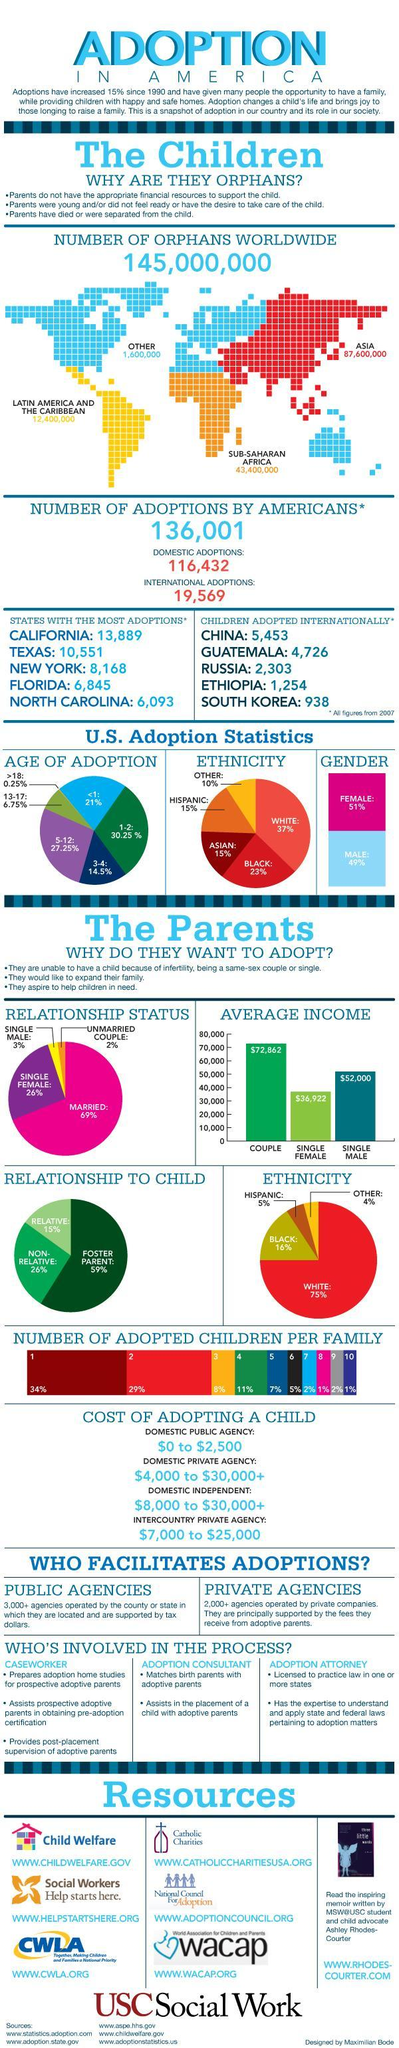What percentage of Asians go for adoption?
Answer the question with a short phrase. 15% What is the average income of single female parent? $36,922 Couples or people in what relationship adopt maximum? MARRIED How many children from China were adopted in 2007? 5,453 In what percentage of cases are the children non-related? 26% Who is responsible for legal adoption matters? ADOPTION ATTORNEY Which gender is higher in adoption statistics? FEMALE What is the age of adoption of 27.25% of children? 5-12 Which ethnicity tops the pie chart in terms of ethnicity? WHITE Who charges the least while adopting? DOMESTIC PUBLIC AGENCY Which state had the third most number of adoptions? NEW YORK What is the number of orphans in Africa? 43,400,000 